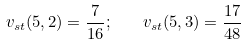<formula> <loc_0><loc_0><loc_500><loc_500>v _ { s t } ( 5 , 2 ) = \frac { 7 } { 1 6 } ; \quad v _ { s t } ( 5 , 3 ) = \frac { 1 7 } { 4 8 }</formula> 